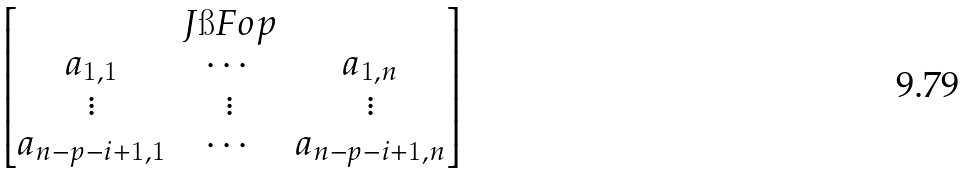Convert formula to latex. <formula><loc_0><loc_0><loc_500><loc_500>\begin{bmatrix} & J \i F o p & \\ a _ { 1 , 1 } & \cdots & a _ { 1 , n } \\ \vdots & \vdots & \vdots \\ a _ { n - p - i + 1 , 1 } & \cdots & a _ { n - p - i + 1 , n } \\ \end{bmatrix}</formula> 